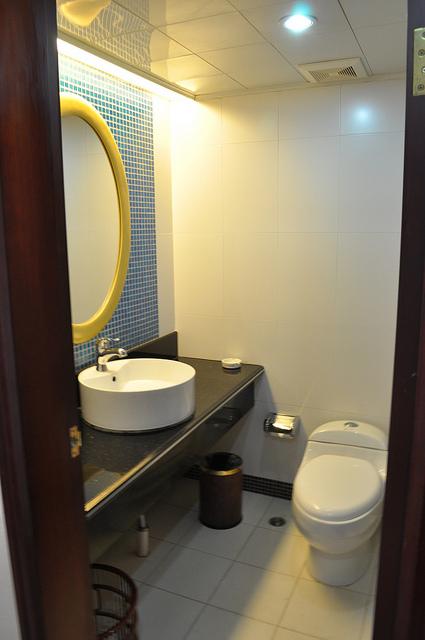How many rolls of Toilet tissue do you see?
Keep it brief. 0. What room is this?
Give a very brief answer. Bathroom. What is the shape of the mirror?
Keep it brief. Oval. 